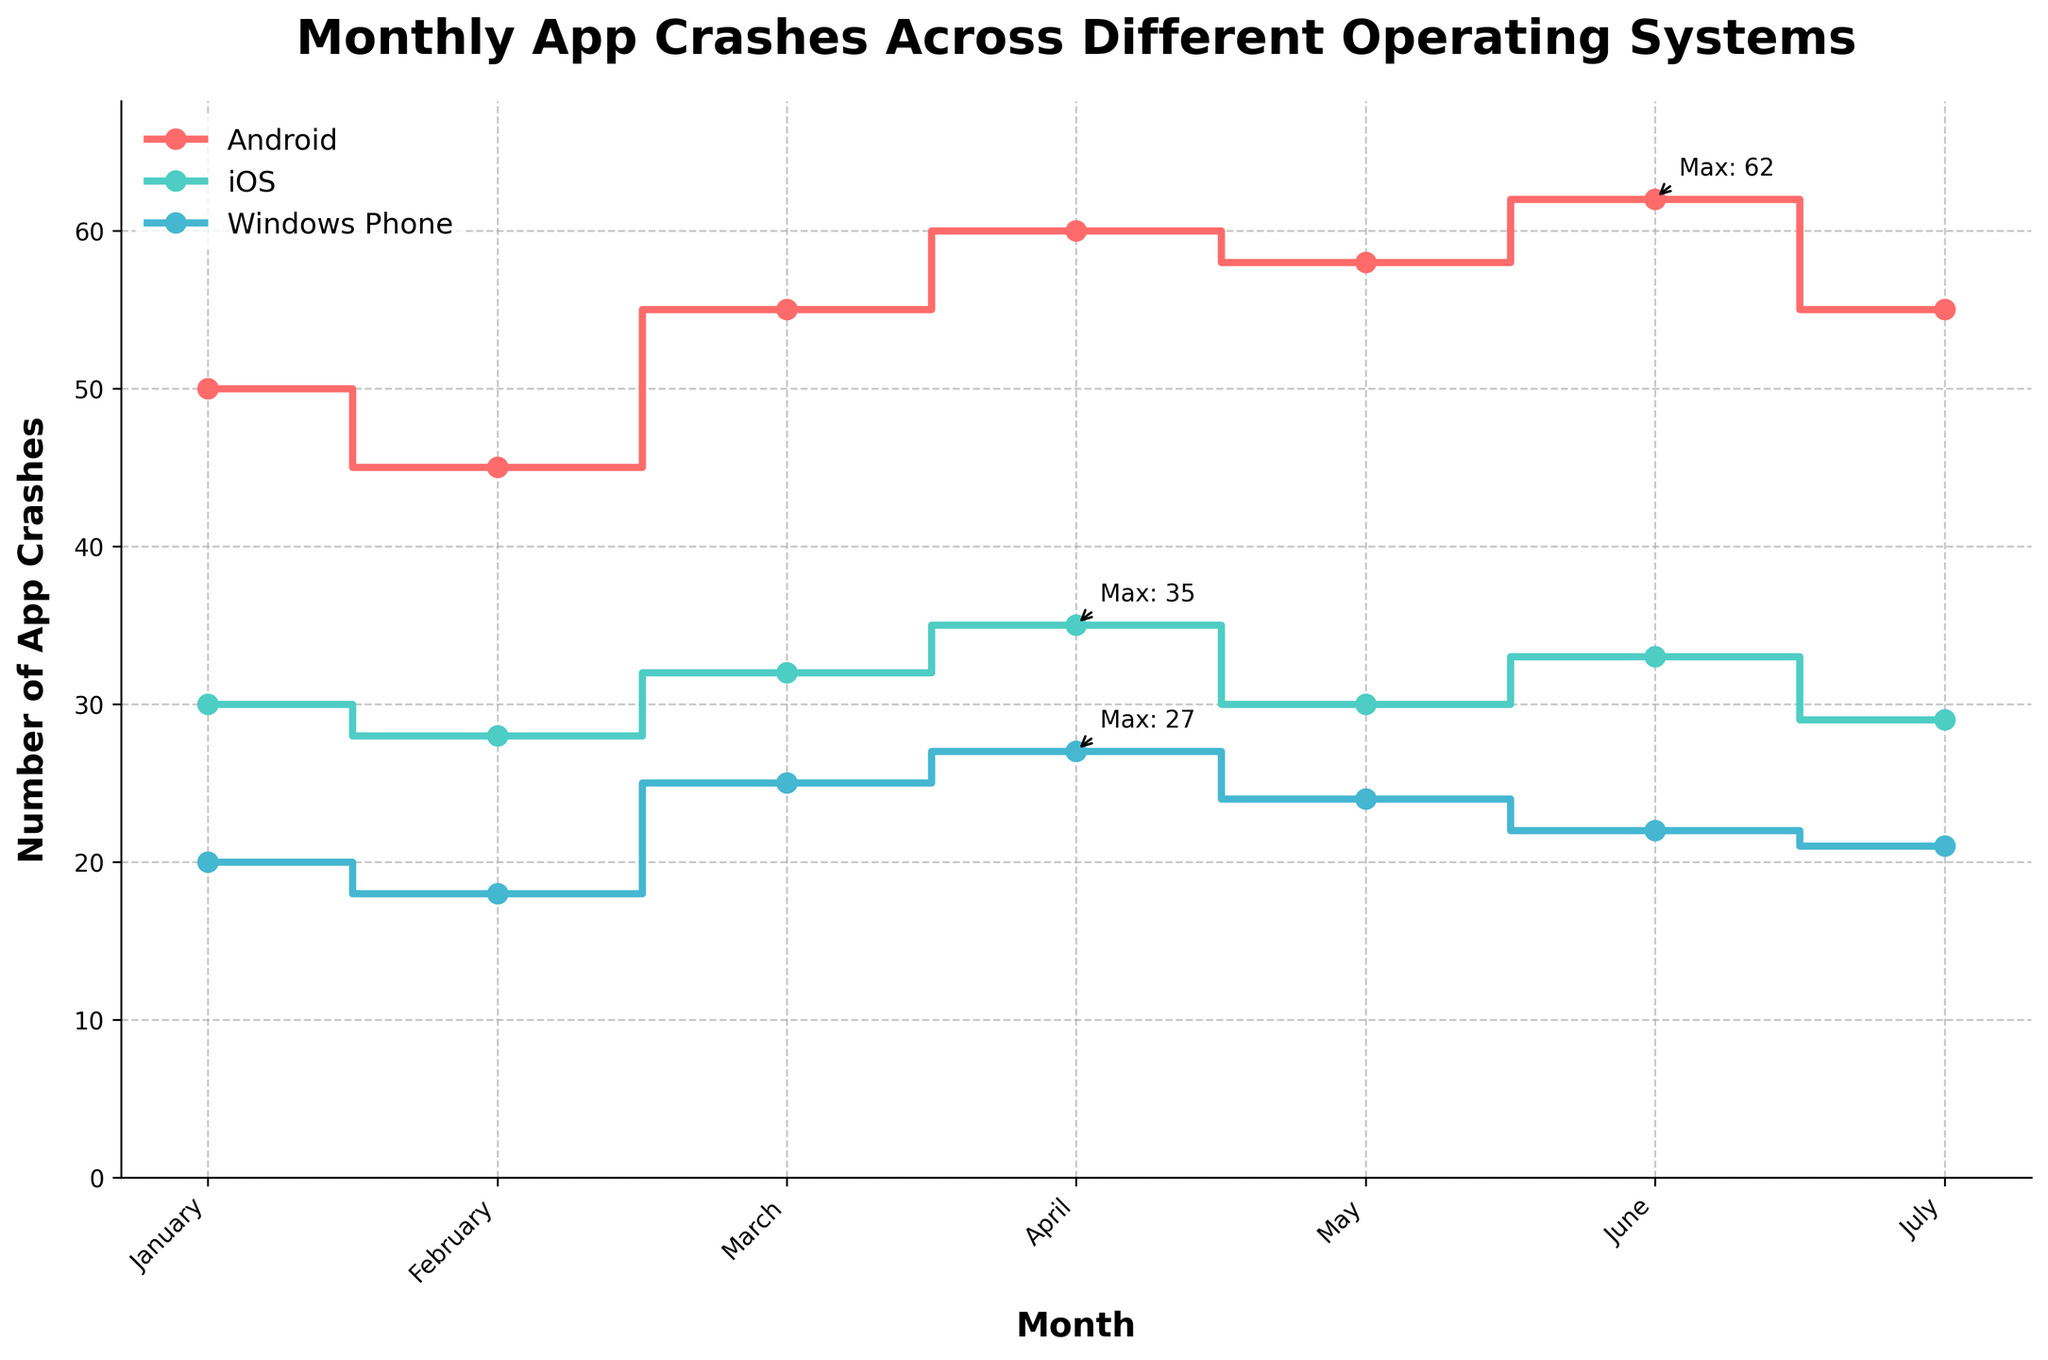What is the title of the plot? The title is the main heading of the plot, typically displayed at the top. It gives a brief description of what the plot represents.
Answer: Monthly App Crashes Across Different Operating Systems Which month had the highest number of app crashes on Android? Look for the highest data point on the Android line and trace it back to the corresponding month on the x-axis.
Answer: June How many app crashes were recorded for iOS in May? Identify the point for iOS in May on the plot and read the y-axis value directly.
Answer: 30 Compare the number of crashes between February and July for Windows Phone. Locate the points for Windows Phone in February and July, and compare their respective values on the y-axis. February has 18 crashes and July has 21 crashes.
Answer: February had 3 fewer crashes than July What is the average number of crashes for iOS over the seven months? Add the number of iOS crashes for each month and divide by the number of months. (30 + 28 + 32 + 35 + 30 + 33 + 29) / 7 = 31
Answer: 31 Which operating system had the least number of crashes overall? Compare the total number of crashes across all months for each operating system and determine which sum is the smallest.
Answer: Windows Phone In which month did all operating systems have the smallest total number of crashes combined? Add the crashes for Android, iOS, and Windows Phone for each month and identify the month with the smallest sum. January has 50 + 30 + 20 = 100.
Answer: February (91) Did any operating system have a consistent increase in crashes month-over-month? Examine each line to see if there is a steady upward trend without any decreases across months.
Answer: No How did the number of crashes in April compare to May for Android? Find the points for Android in April and May, and compare their y-axis values. April had 60 crashes, and May had 58 crashes.
Answer: April had 2 more crashes than May Which month showed the largest increase in crashes for Windows Phone compared to the previous month? Calculate the difference in crashes between consecutive months for Windows Phone and identify the month with the largest increase. March showed the largest increase (20 to 25, a 5-crash increase).
Answer: March 